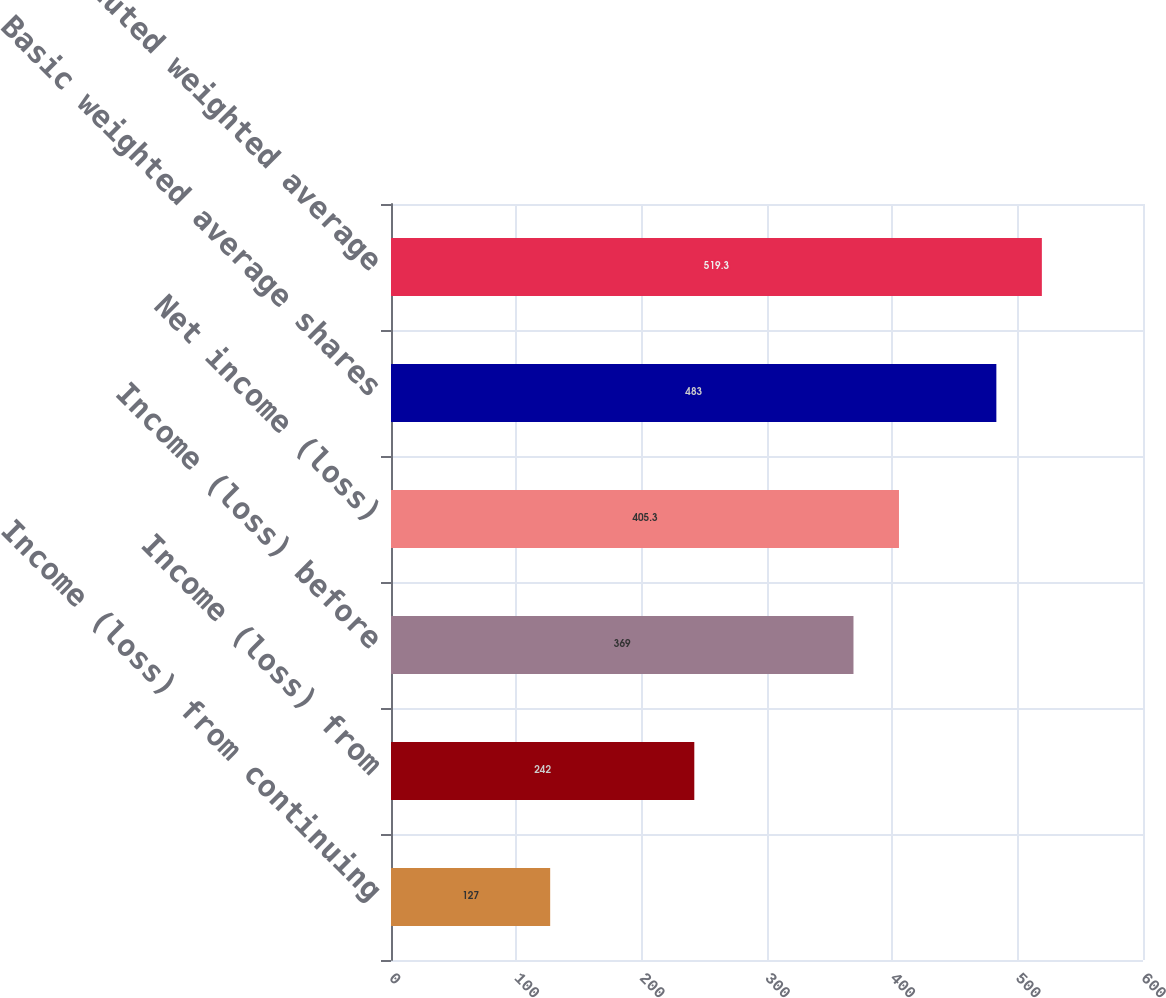Convert chart. <chart><loc_0><loc_0><loc_500><loc_500><bar_chart><fcel>Income (loss) from continuing<fcel>Income (loss) from<fcel>Income (loss) before<fcel>Net income (loss)<fcel>Basic weighted average shares<fcel>Diluted weighted average<nl><fcel>127<fcel>242<fcel>369<fcel>405.3<fcel>483<fcel>519.3<nl></chart> 